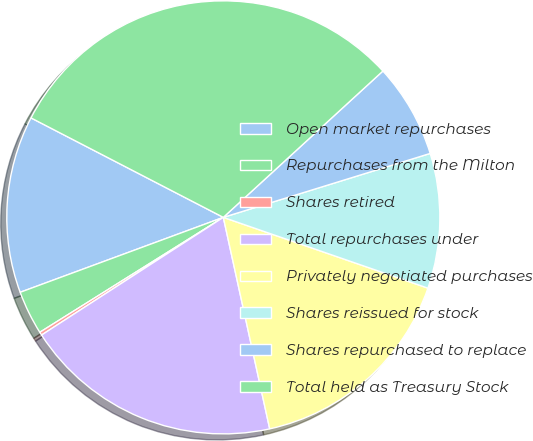<chart> <loc_0><loc_0><loc_500><loc_500><pie_chart><fcel>Open market repurchases<fcel>Repurchases from the Milton<fcel>Shares retired<fcel>Total repurchases under<fcel>Privately negotiated purchases<fcel>Shares reissued for stock<fcel>Shares repurchased to replace<fcel>Total held as Treasury Stock<nl><fcel>13.22%<fcel>3.28%<fcel>0.24%<fcel>19.29%<fcel>16.26%<fcel>10.07%<fcel>7.04%<fcel>30.59%<nl></chart> 